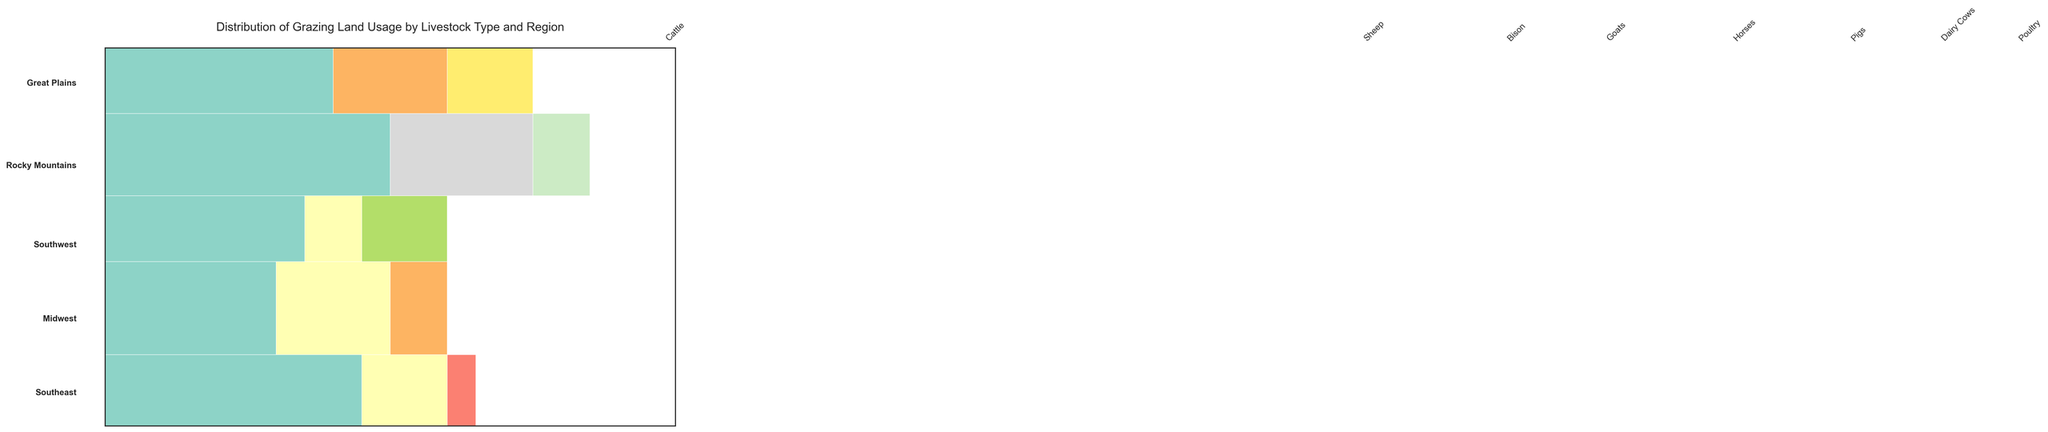What is the title of the figure? The title of the figure is typically displayed prominently at the top and it provides a succinct summary of the visualized data. In this case, the title is "Distribution of Grazing Land Usage by Livestock Type and Region".
Answer: Distribution of Grazing Land Usage by Livestock Type and Region Which region has the highest percentage of land usage for cattle? To answer this, look at the portion of the mosaic plot representing cattle for each region and identify the one with the largest area. The Midwest region has the largest percentage of land usage for cattle at 50%.
Answer: Midwest How many different types of livestock are represented in the Great Plains region? The Great Plains region will have sections in the mosaic plot represented by different colors for each livestock type. There are three different types of livestock represented here: Cattle, Sheep, and Bison.
Answer: 3 What is the total percentage of land usage for sheep across all regions? Sum the percentages for sheep in each region. Great Plains (15) + Rocky Mountains (20) + Southwest (10) = 45%.
Answer: 45% Which region has the most diversified livestock usage in terms of types of livestock? A region with the most types of livestock represented would be considered the most diversified. The Rocky Mountains region has three different types of livestock: Cattle, Sheep, and Goats.
Answer: Rocky Mountains Which livestock type has the least representation across all regions? To determine this, sum up the percentages for each livestock type and compare. Bison is only present in the Great Plains with 5%, which is the lowest total across all regions.
Answer: Bison Compare cattle land usage between the Midwest and the Southeast. Which has a higher percentage? Look at the sections of the mosaic plot representing cattle usage in both regions. The Midwest has 50%, while the Southeast has 40%. The Midwest has a higher percentage.
Answer: Midwest In the Great Plains, what percentage of land is used by livestock other than cattle? Subtract the percentage of land used by cattle from the total land usage for the Great Plains. Total is 100%, and cattle usage is 45%. Thus, 100% - 45% = 55%.
Answer: 55% List the regions where goats are part of the livestock. Observe the mosaic plot sections colored for goats and identify the regions these sections belong to. Goats are represented in the Rocky Mountains and Southeast regions.
Answer: Rocky Mountains, Southeast Which region has the highest total land usage for dairy cows, pigs, and poultry combined? Sum the percentages for dairy cows, pigs, and poultry across all regions. Midwest (Dairy Cows 10% + Pigs 25% + Poultry 0%) = 35%, Southeast (Dairy Cows 0% + Pigs 0% + Poultry 15%) = 15%. The Midwest has the highest total at 35%.
Answer: Midwest 